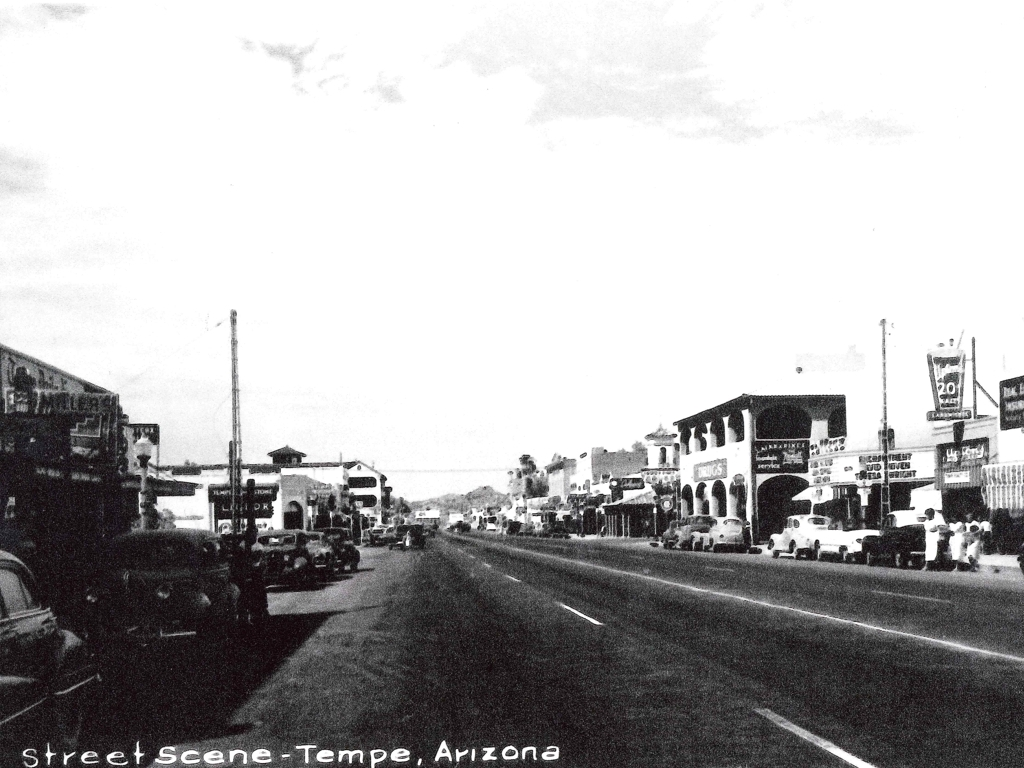What kind of businesses might have been found in a street scene like this? A street scene from the era indicated by this photo would likely include a range of businesses such as service stations, diners, general stores, movie theaters with prominent marquee signs, and possibly specialty shops like barbers and pharmacies. This reflects a time when downtown areas were bustling centers of commerce and social gathering. 